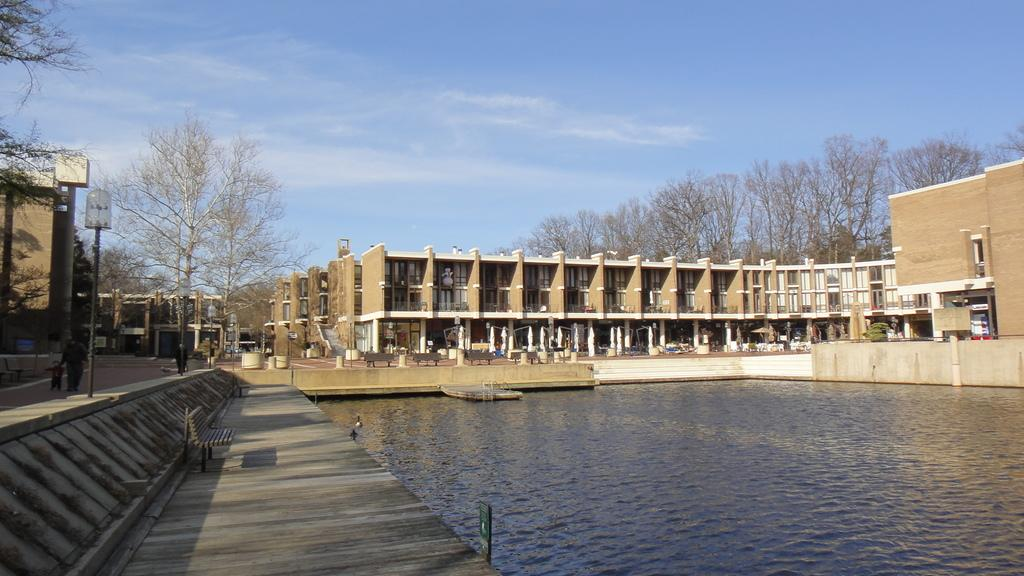What type of structure is present in the image? There is a building in the image. What can be found near the building? There are benches and stairs visible in the image. What natural elements are present in the image? There is water, trees, and the sky visible in the image. What is the condition of the sky in the image? The sky is visible in the image, and there are clouds present. Can you see the wing of an airplane in the image? There is no wing of an airplane visible in the image. What station is depicted in the image? There is no station present in the image. 